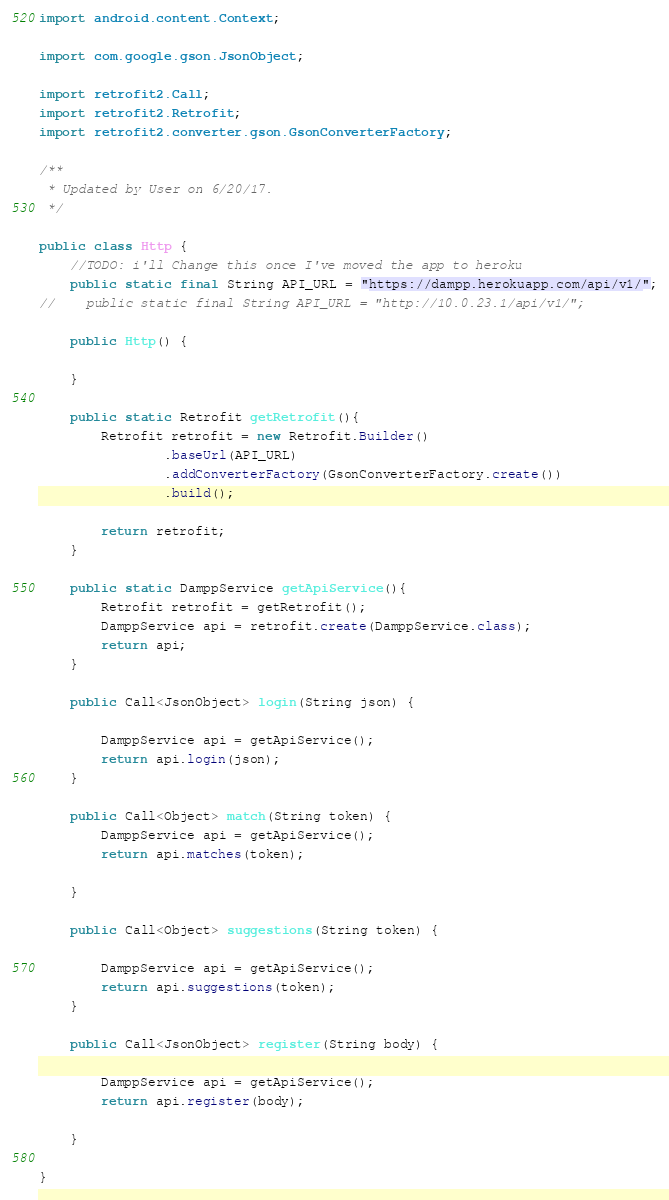Convert code to text. <code><loc_0><loc_0><loc_500><loc_500><_Java_>
import android.content.Context;

import com.google.gson.JsonObject;

import retrofit2.Call;
import retrofit2.Retrofit;
import retrofit2.converter.gson.GsonConverterFactory;

/**
 * Updated by User on 6/20/17.
 */

public class Http {
    //TODO: i'll Change this once I've moved the app to heroku
    public static final String API_URL = "https://dampp.herokuapp.com/api/v1/";
//    public static final String API_URL = "http://10.0.23.1/api/v1/";

    public Http() {

    }

    public static Retrofit getRetrofit(){
        Retrofit retrofit = new Retrofit.Builder()
                .baseUrl(API_URL)
                .addConverterFactory(GsonConverterFactory.create())
                .build();

        return retrofit;
    }

    public static DamppService getApiService(){
        Retrofit retrofit = getRetrofit();
        DamppService api = retrofit.create(DamppService.class);
        return api;
    }

    public Call<JsonObject> login(String json) {

        DamppService api = getApiService();
        return api.login(json);
    }

    public Call<Object> match(String token) {
        DamppService api = getApiService();
        return api.matches(token);

    }

    public Call<Object> suggestions(String token) {

        DamppService api = getApiService();
        return api.suggestions(token);
    }

    public Call<JsonObject> register(String body) {

        DamppService api = getApiService();
        return api.register(body);

    }

}
</code> 